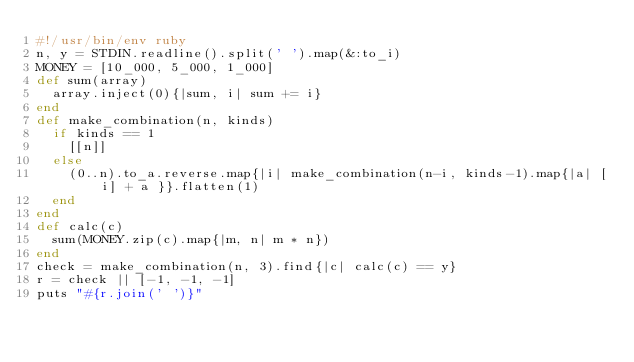Convert code to text. <code><loc_0><loc_0><loc_500><loc_500><_Ruby_>#!/usr/bin/env ruby
n, y = STDIN.readline().split(' ').map(&:to_i)
MONEY = [10_000, 5_000, 1_000]
def sum(array)
  array.inject(0){|sum, i| sum += i}
end
def make_combination(n, kinds)
  if kinds == 1
    [[n]]
  else
    (0..n).to_a.reverse.map{|i| make_combination(n-i, kinds-1).map{|a| [i] + a }}.flatten(1)
  end
end
def calc(c)
  sum(MONEY.zip(c).map{|m, n| m * n})
end
check = make_combination(n, 3).find{|c| calc(c) == y}
r = check || [-1, -1, -1]
puts "#{r.join(' ')}"
</code> 